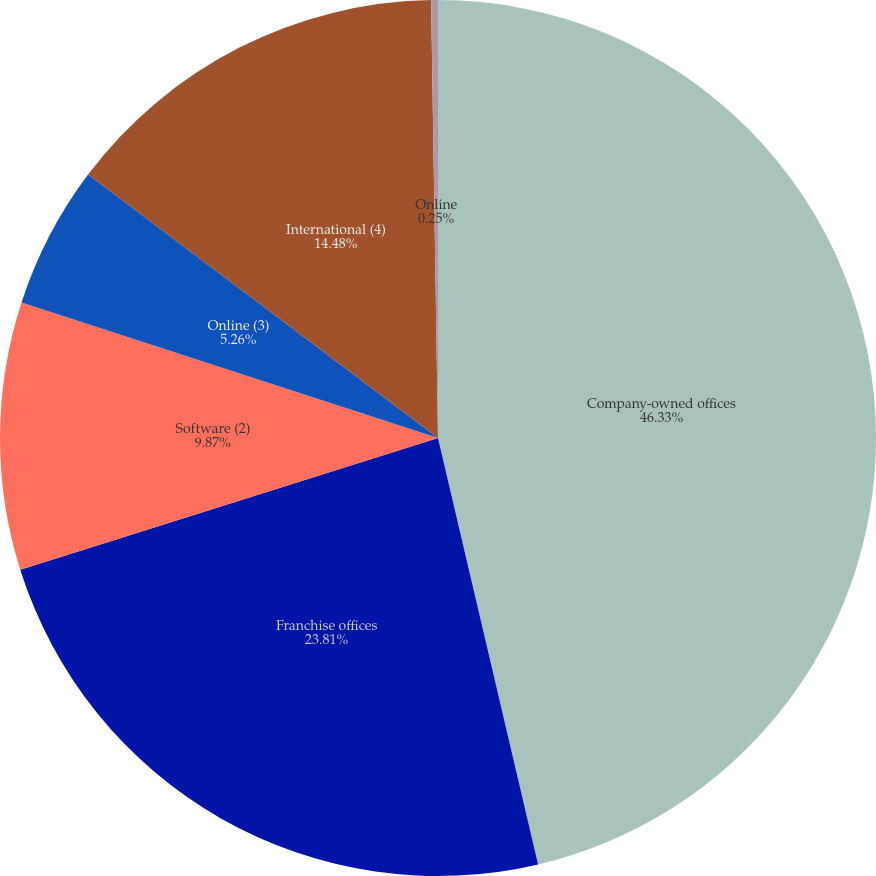Convert chart. <chart><loc_0><loc_0><loc_500><loc_500><pie_chart><fcel>Company-owned offices<fcel>Franchise offices<fcel>Software (2)<fcel>Online (3)<fcel>International (4)<fcel>Online<nl><fcel>46.33%<fcel>23.81%<fcel>9.87%<fcel>5.26%<fcel>14.48%<fcel>0.25%<nl></chart> 